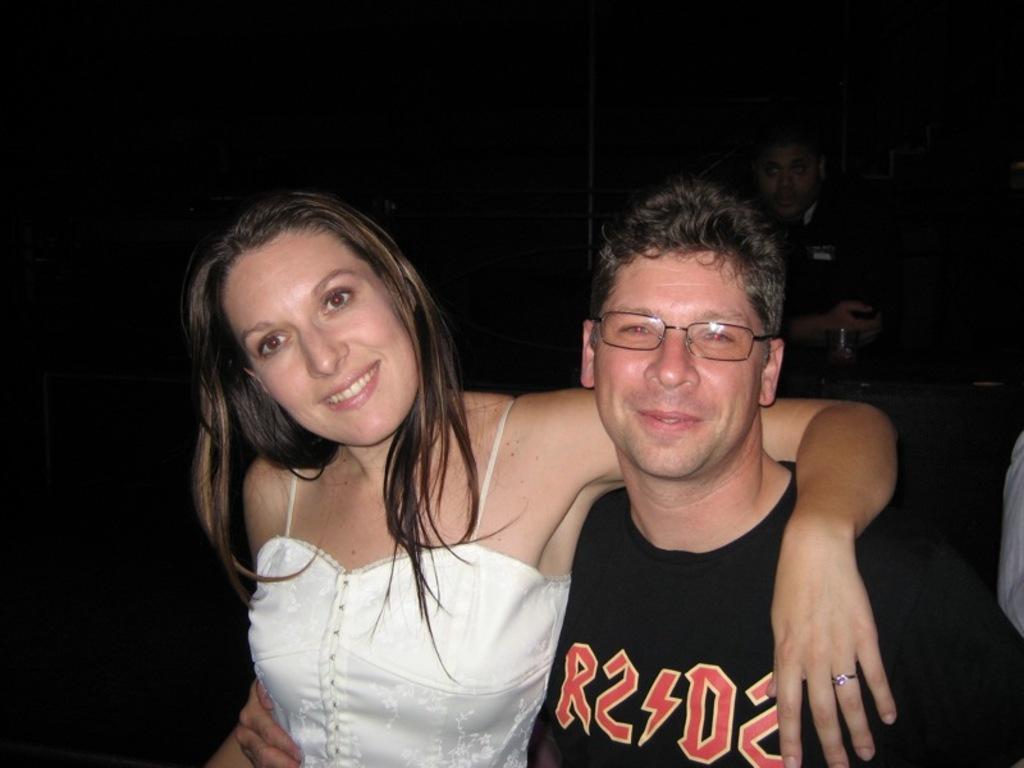In one or two sentences, can you explain what this image depicts? In the picture I can see a man and a woman are standing and smiling. The man is wearing spectacles and a black color t-shirt and the woman is wearing a white color dress. The background of the image is dark. 